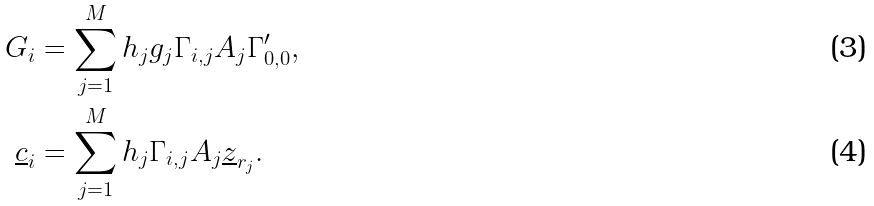Convert formula to latex. <formula><loc_0><loc_0><loc_500><loc_500>G _ { i } & = \sum _ { j = 1 } ^ { M } h _ { j } g _ { j } \Gamma _ { i , j } A _ { j } \Gamma ^ { \prime } _ { 0 , 0 } , \\ \underline { c } _ { i } & = \sum _ { j = 1 } ^ { M } h _ { j } \Gamma _ { i , j } A _ { j } \underline { z } _ { r _ { j } } .</formula> 